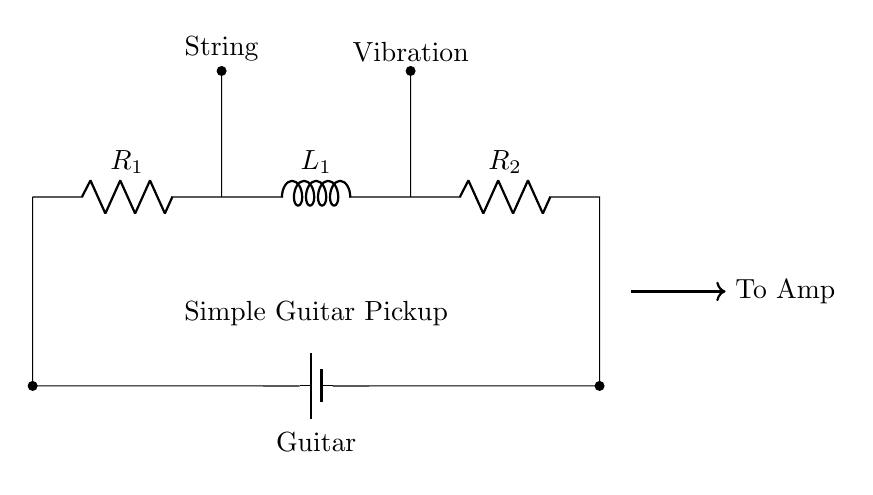What is the total resistance in this circuit? The total resistance is the sum of the resistors in series: R1 + R2. Since only R1 and R2 are visible, we do not have their values given. But the formula for total resistance is clear.
Answer: R1 + R2 What component is used to pick up the guitar string vibrations? The component responsible for picking up vibrations from the guitar string is the inductor (L1). It converts the string's motion into an electrical signal.
Answer: Inductor How many resistors are in this circuit? There are two resistors in the circuit, labeled as R1 and R2. Each is connected in series.
Answer: Two What happens to the current when the guitar string vibrates? When the guitar string vibrates, it causes a change in magnetic field around the inductor (L1), inducing a current flow in the circuit. This follows the principle of electromagnetic induction.
Answer: Induced current What is the role of the battery in this circuit? The battery provides the electrical energy necessary for the circuit to operate, supplying the voltage that drives current through the resistors and inductor.
Answer: Power supply How would an increase in resistance affect the circuit? An increase in resistance (R1 or R2) would lead to a decrease in the overall current flowing from the battery, due to Ohm’s law (I = V/R). The circuit would be less effective in transmitting signals.
Answer: Decrease current 